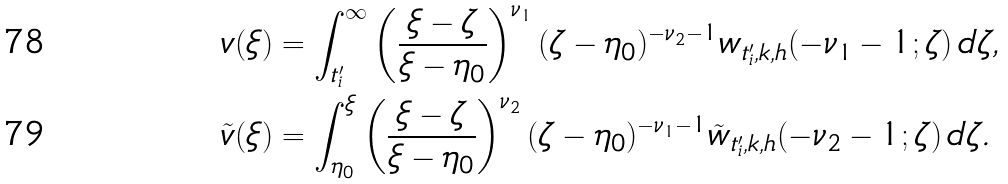<formula> <loc_0><loc_0><loc_500><loc_500>v ( \xi ) & = \int _ { t ^ { \prime } _ { i } } ^ { \infty } \left ( \frac { \xi - \zeta } { \xi - \eta _ { 0 } } \right ) ^ { \nu _ { 1 } } ( \zeta - \eta _ { 0 } ) ^ { - \nu _ { 2 } - 1 } w _ { t ^ { \prime } _ { i } , k , h } ( - \nu _ { 1 } - 1 ; \zeta ) \, d \zeta , \\ \tilde { v } ( \xi ) & = \int _ { \eta _ { 0 } } ^ { \xi } \left ( \frac { \xi - \zeta } { \xi - \eta _ { 0 } } \right ) ^ { \nu _ { 2 } } ( \zeta - \eta _ { 0 } ) ^ { - \nu _ { 1 } - 1 } \tilde { w } _ { t ^ { \prime } _ { i } , k , h } ( - \nu _ { 2 } - 1 ; \zeta ) \, d \zeta .</formula> 